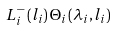Convert formula to latex. <formula><loc_0><loc_0><loc_500><loc_500>L ^ { - } _ { i } \left ( l _ { i } \right ) \Theta _ { i } \left ( \lambda _ { i } , l _ { i } \right )</formula> 